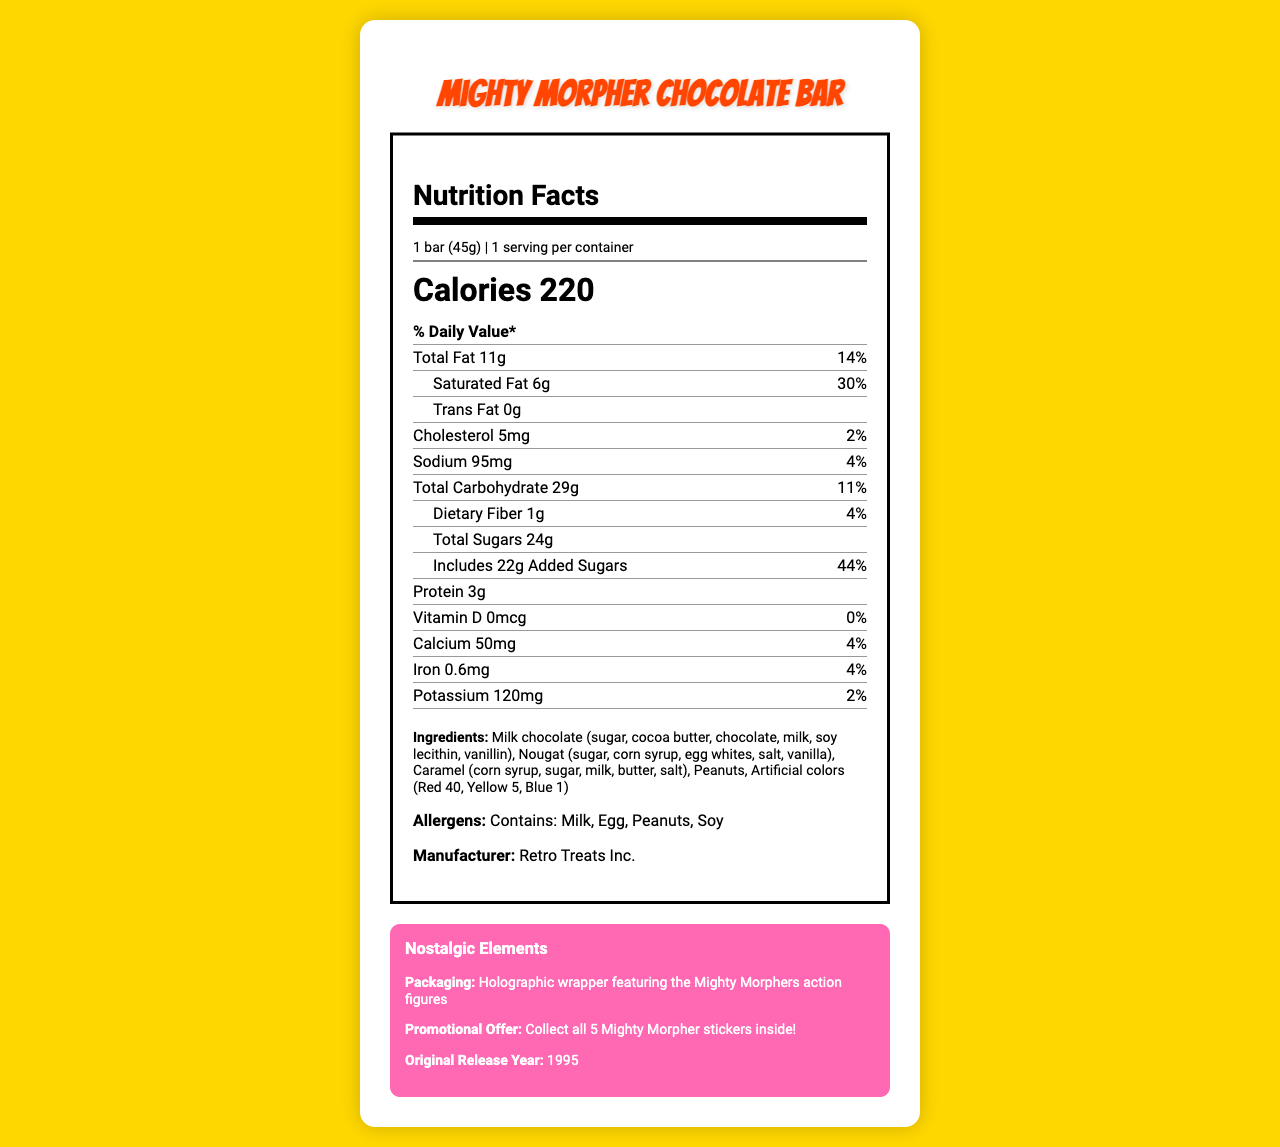what is the product name? The product name is displayed at the top of the document in large, bold text.
Answer: Mighty Morpher Chocolate Bar what is the serving size? The serving size is stated right under the "Nutrition Facts" heading.
Answer: 1 bar (45g) how many calories are in a single bar? The calories are displayed prominently under the serving information.
Answer: 220 what percentage of daily value does the total fat content represent? The total fat daily value percentage is shown next to the total fat amount.
Answer: 14% what is the amount of added sugars? The added sugars amount is listed alongside "Includes 22g Added Sugars".
Answer: 22g how many grams of protein are in the candy bar? The protein content is listed near the bottom of the nutrient information.
Answer: 3g what allergens are present in the product? The allergens are listed as "Contains: Milk, Egg, Peanuts, Soy".
Answer: Milk, Egg, Peanuts, Soy who is the manufacturer of this product? The manufacturer is listed at the bottom of the document.
Answer: Retro Treats Inc. what year was this candy bar originally released? The original release year is provided under "Nostalgic Elements".
Answer: 1995 which of the following is a main ingredient in the Mighty Morpher Chocolate Bar? A. Almonds B. Milk Chocolate C. Dark Chocolate D. Coconut The ingredients list includes "Milk chocolate" but not the other options.
Answer: B how much iron does the candy bar contain? A. 0.4mg B. 0.5mg C. 0.6mg D. 0.7mg The iron content is stated as 0.6mg in the document.
Answer: C does this candy bar have any Vitamin D? The nutrient information shows Vitamin D as 0mcg, which is 0% of the daily value.
Answer: No how much sodium is present in this candy bar? The sodium amount is listed clearly next to "Sodium" in the document.
Answer: 95mg what is the packaging style of this product? The nostalgic elements section describes the packaging style.
Answer: Holographic wrapper featuring the Mighty Morphers action figures summarize the content provided in the document. The overall summary captures the nutrition facts, key ingredients, allergen information, and nostalgic promotional details of the chocolate bar.
Answer: The document provides the nutrition facts, ingredient list, allergens, and nostalgic elements for the Mighty Morpher Chocolate Bar. It includes details on serving size, calories, various nutrients with their amounts and daily values, and special nostalgic features like packaging and promotional offers. how many grams of dietary fiber does the candy bar contain? The dietary fiber content is listed as 1g in the nutrient information.
Answer: 1g does the candy bar contain artificial colors? The ingredients list includes "Artificial colors (Red 40, Yellow 5, Blue 1)".
Answer: Yes what is the exact percentage of the daily value for calcium provided by the candy bar? The nutrient information states that the calcium daily value is 4%.
Answer: 4% how many different types of nostalgic elements are mentioned in the document? The document mentions three nostalgic elements: packaging, promotional offer, and original release year.
Answer: Three how many servings per container does the document indicate? The serving size information states there is 1 serving per container.
Answer: 1 how much total carbohydrate is in the candy bar? The total carbohydrate content is listed clearly as 29g.
Answer: 29g at which store can I buy this product? The document does not provide any information on where to buy the product.
Answer: Cannot be determined 